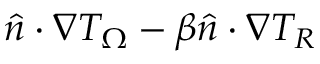<formula> <loc_0><loc_0><loc_500><loc_500>\hat { n } \cdot \nabla T _ { \Omega } - \beta \hat { n } \cdot \nabla T _ { R }</formula> 